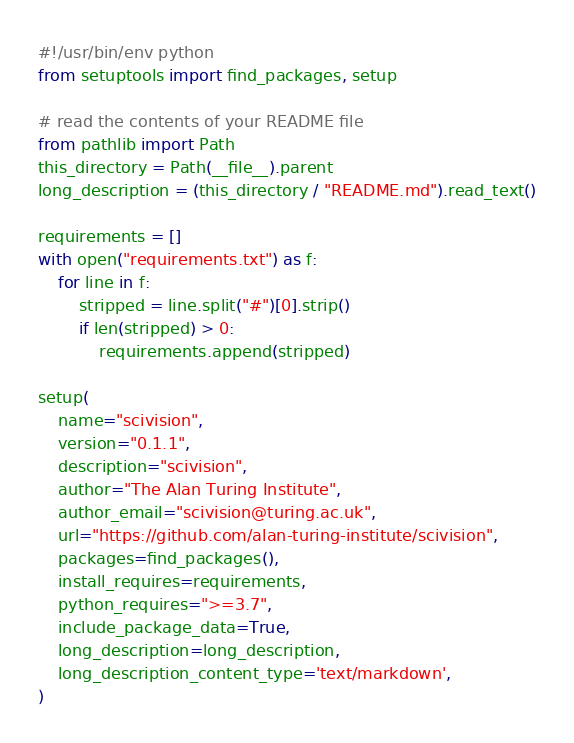<code> <loc_0><loc_0><loc_500><loc_500><_Python_>#!/usr/bin/env python
from setuptools import find_packages, setup

# read the contents of your README file
from pathlib import Path
this_directory = Path(__file__).parent
long_description = (this_directory / "README.md").read_text()

requirements = []
with open("requirements.txt") as f:
    for line in f:
        stripped = line.split("#")[0].strip()
        if len(stripped) > 0:
            requirements.append(stripped)

setup(
    name="scivision",
    version="0.1.1",
    description="scivision",
    author="The Alan Turing Institute",
    author_email="scivision@turing.ac.uk",
    url="https://github.com/alan-turing-institute/scivision",
    packages=find_packages(),
    install_requires=requirements,
    python_requires=">=3.7",
    include_package_data=True,
    long_description=long_description,
    long_description_content_type='text/markdown',
)
</code> 